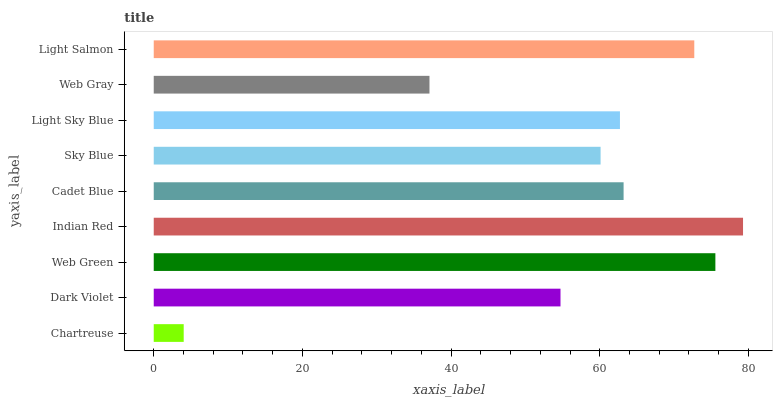Is Chartreuse the minimum?
Answer yes or no. Yes. Is Indian Red the maximum?
Answer yes or no. Yes. Is Dark Violet the minimum?
Answer yes or no. No. Is Dark Violet the maximum?
Answer yes or no. No. Is Dark Violet greater than Chartreuse?
Answer yes or no. Yes. Is Chartreuse less than Dark Violet?
Answer yes or no. Yes. Is Chartreuse greater than Dark Violet?
Answer yes or no. No. Is Dark Violet less than Chartreuse?
Answer yes or no. No. Is Light Sky Blue the high median?
Answer yes or no. Yes. Is Light Sky Blue the low median?
Answer yes or no. Yes. Is Light Salmon the high median?
Answer yes or no. No. Is Sky Blue the low median?
Answer yes or no. No. 